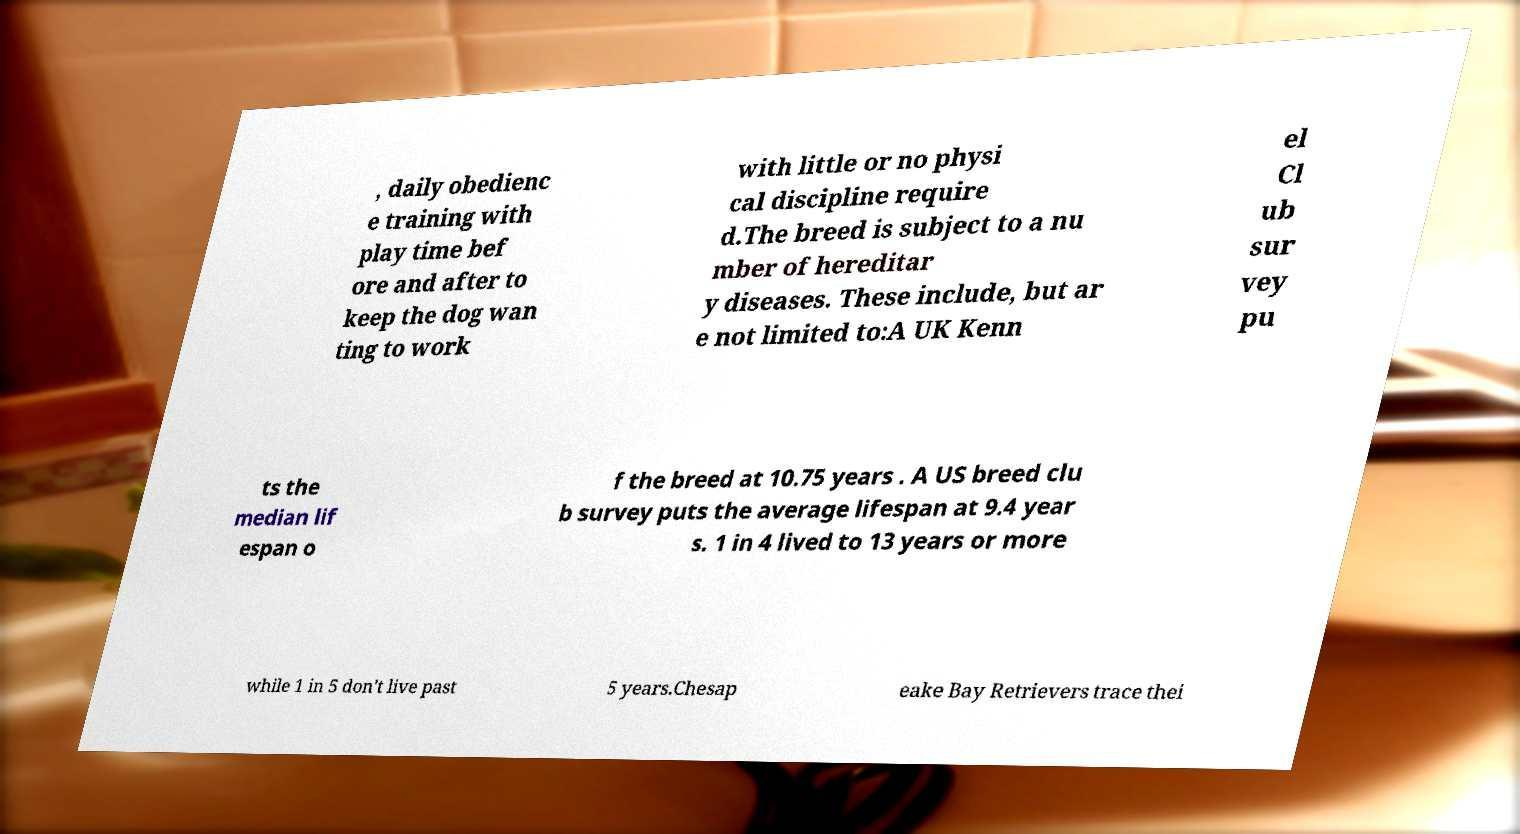I need the written content from this picture converted into text. Can you do that? , daily obedienc e training with play time bef ore and after to keep the dog wan ting to work with little or no physi cal discipline require d.The breed is subject to a nu mber of hereditar y diseases. These include, but ar e not limited to:A UK Kenn el Cl ub sur vey pu ts the median lif espan o f the breed at 10.75 years . A US breed clu b survey puts the average lifespan at 9.4 year s. 1 in 4 lived to 13 years or more while 1 in 5 don't live past 5 years.Chesap eake Bay Retrievers trace thei 